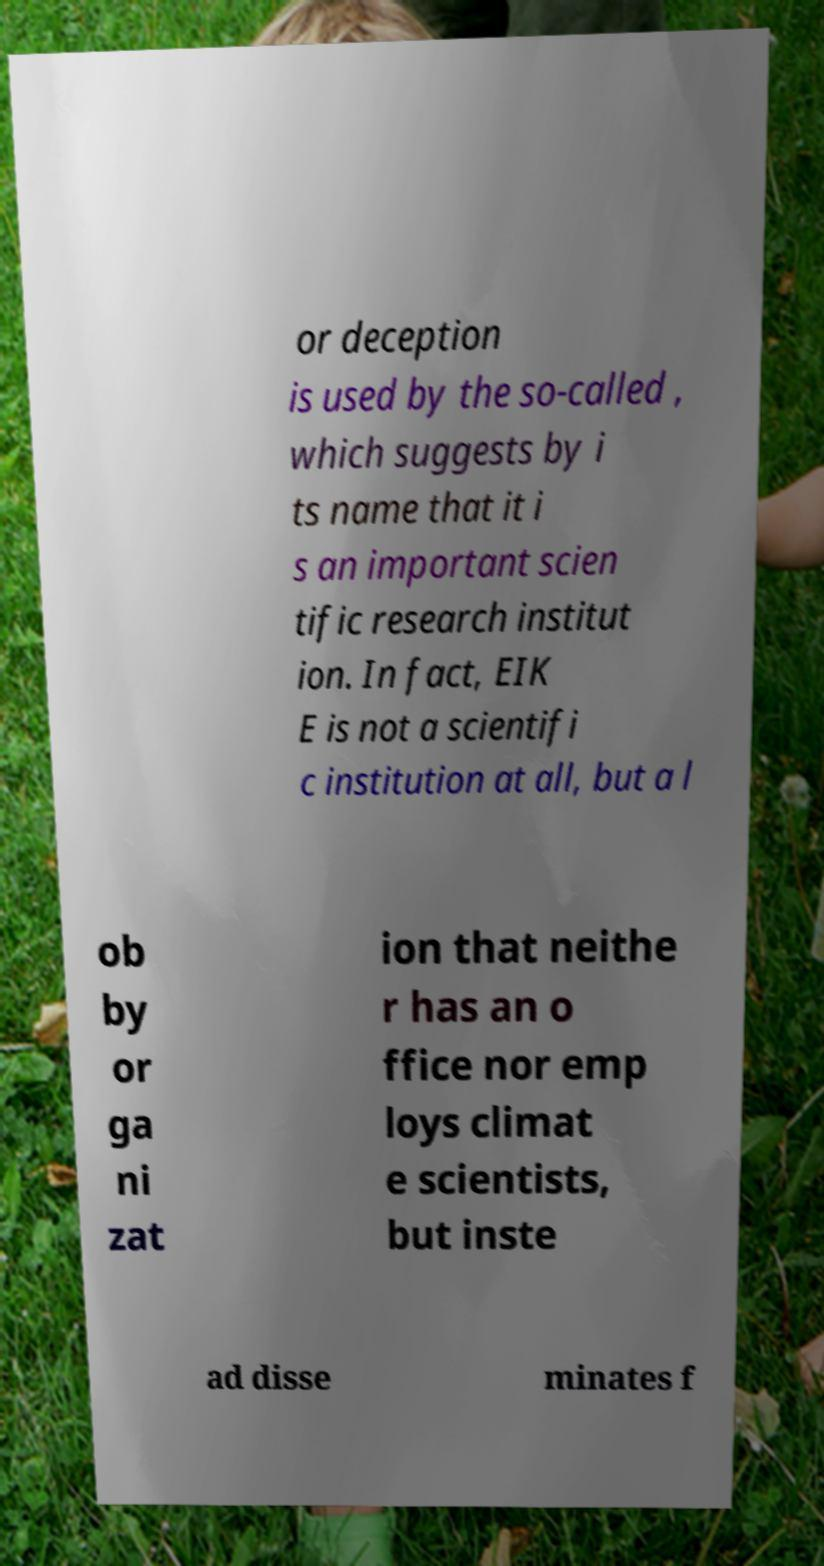There's text embedded in this image that I need extracted. Can you transcribe it verbatim? or deception is used by the so-called , which suggests by i ts name that it i s an important scien tific research institut ion. In fact, EIK E is not a scientifi c institution at all, but a l ob by or ga ni zat ion that neithe r has an o ffice nor emp loys climat e scientists, but inste ad disse minates f 